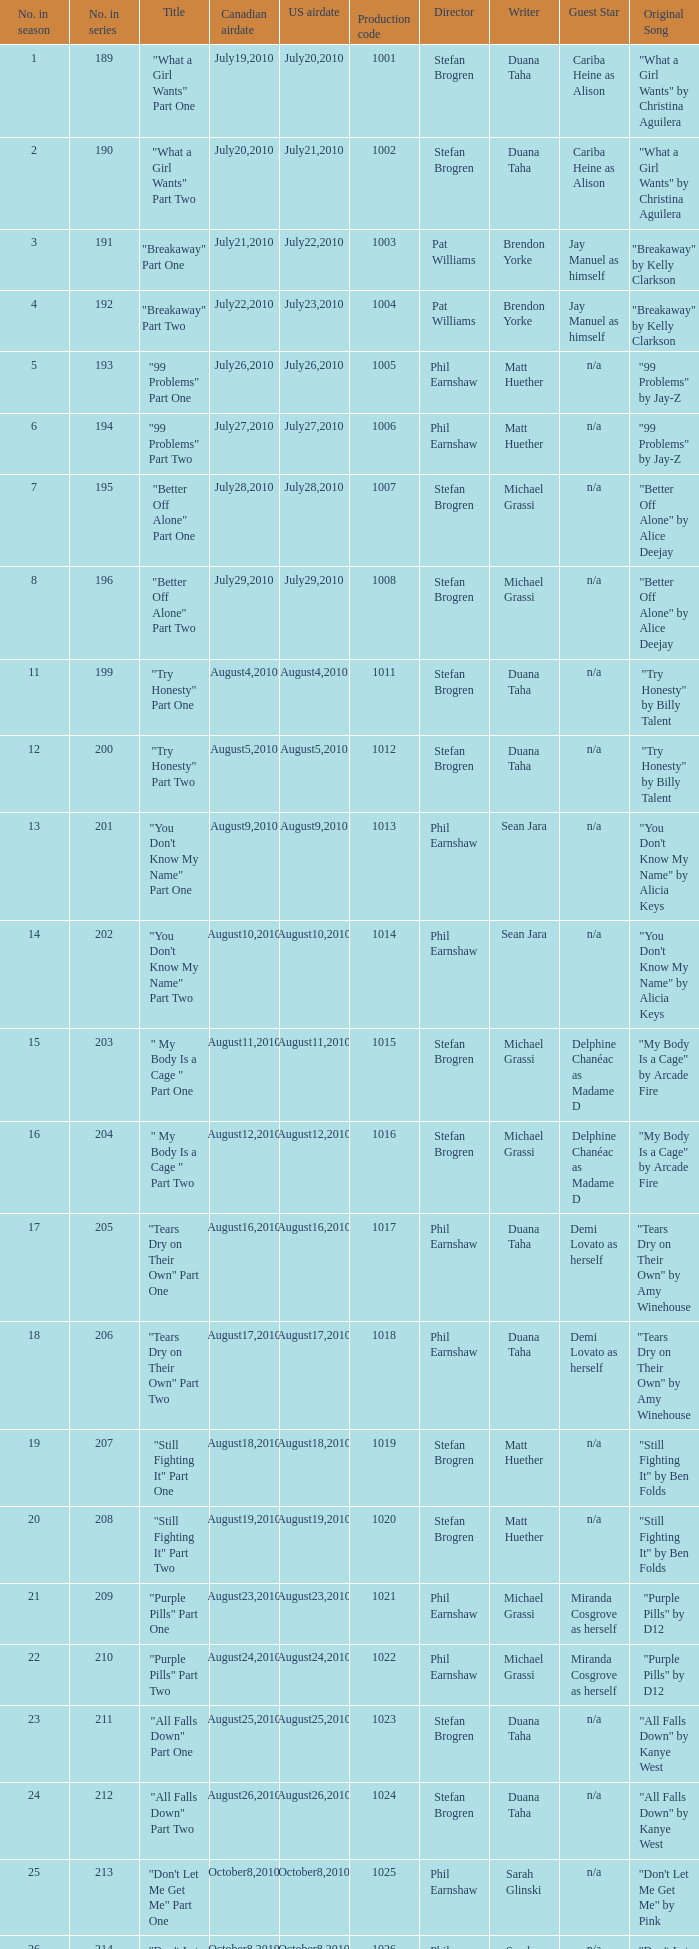What was the us airdate of "love lockdown" part one? October15,2010. 